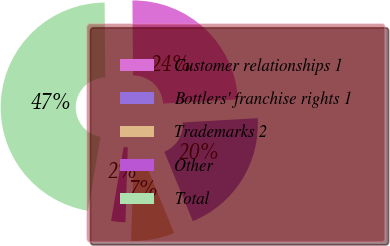Convert chart to OTSL. <chart><loc_0><loc_0><loc_500><loc_500><pie_chart><fcel>Customer relationships 1<fcel>Bottlers' franchise rights 1<fcel>Trademarks 2<fcel>Other<fcel>Total<nl><fcel>24.22%<fcel>19.72%<fcel>6.69%<fcel>2.19%<fcel>47.18%<nl></chart> 